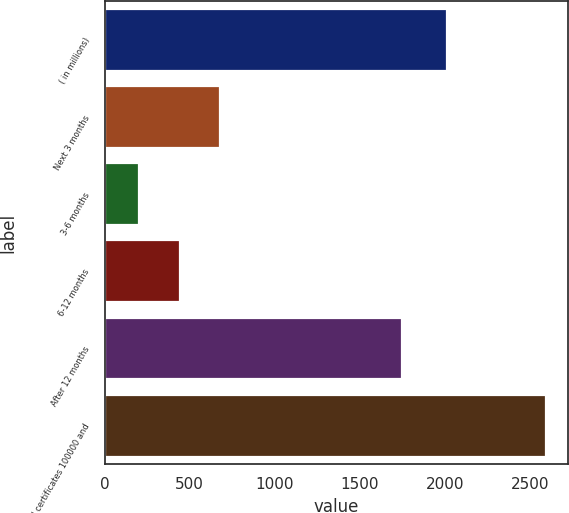Convert chart to OTSL. <chart><loc_0><loc_0><loc_500><loc_500><bar_chart><fcel>( in millions)<fcel>Next 3 months<fcel>3-6 months<fcel>6-12 months<fcel>After 12 months<fcel>Total certificates 100000 and<nl><fcel>2015<fcel>680.8<fcel>203<fcel>441.9<fcel>1751<fcel>2592<nl></chart> 